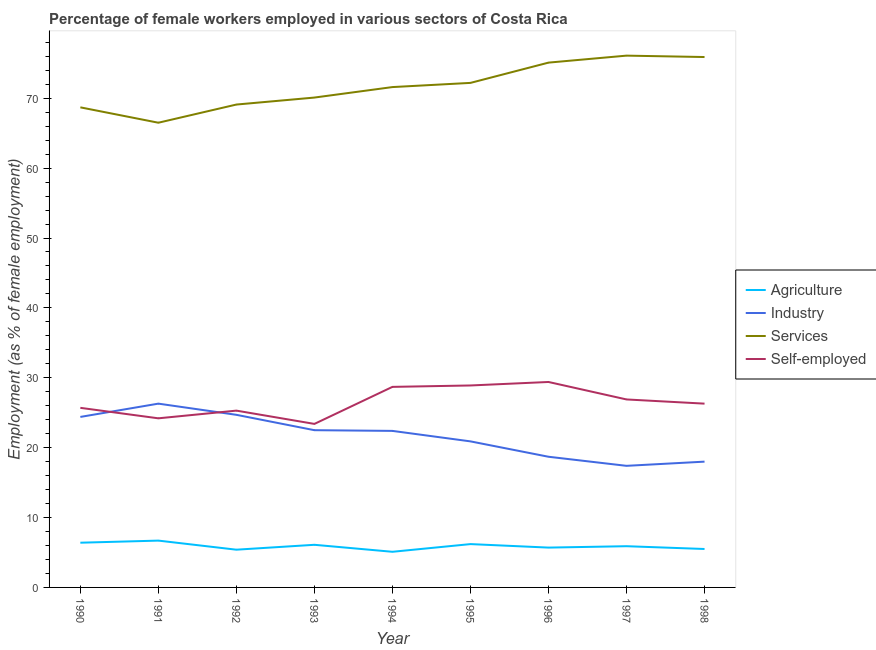Does the line corresponding to percentage of self employed female workers intersect with the line corresponding to percentage of female workers in services?
Give a very brief answer. No. Is the number of lines equal to the number of legend labels?
Provide a short and direct response. Yes. What is the percentage of female workers in services in 1993?
Make the answer very short. 70.1. Across all years, what is the maximum percentage of female workers in industry?
Your answer should be very brief. 26.3. Across all years, what is the minimum percentage of self employed female workers?
Ensure brevity in your answer.  23.4. In which year was the percentage of female workers in services maximum?
Keep it short and to the point. 1997. In which year was the percentage of female workers in services minimum?
Keep it short and to the point. 1991. What is the total percentage of female workers in services in the graph?
Offer a very short reply. 645.3. What is the difference between the percentage of female workers in industry in 1994 and that in 1997?
Provide a succinct answer. 5. What is the difference between the percentage of female workers in services in 1993 and the percentage of female workers in industry in 1997?
Offer a terse response. 52.7. What is the average percentage of female workers in agriculture per year?
Keep it short and to the point. 5.89. In the year 1996, what is the difference between the percentage of female workers in industry and percentage of self employed female workers?
Ensure brevity in your answer.  -10.7. What is the ratio of the percentage of self employed female workers in 1990 to that in 1996?
Provide a succinct answer. 0.87. Is the percentage of female workers in services in 1995 less than that in 1996?
Ensure brevity in your answer.  Yes. What is the difference between the highest and the second highest percentage of self employed female workers?
Offer a very short reply. 0.5. What is the difference between the highest and the lowest percentage of female workers in services?
Your response must be concise. 9.6. Is it the case that in every year, the sum of the percentage of female workers in agriculture and percentage of self employed female workers is greater than the sum of percentage of female workers in services and percentage of female workers in industry?
Keep it short and to the point. No. Is it the case that in every year, the sum of the percentage of female workers in agriculture and percentage of female workers in industry is greater than the percentage of female workers in services?
Ensure brevity in your answer.  No. Does the percentage of female workers in agriculture monotonically increase over the years?
Your answer should be compact. No. Is the percentage of self employed female workers strictly less than the percentage of female workers in industry over the years?
Make the answer very short. No. How many years are there in the graph?
Give a very brief answer. 9. What is the difference between two consecutive major ticks on the Y-axis?
Make the answer very short. 10. Are the values on the major ticks of Y-axis written in scientific E-notation?
Give a very brief answer. No. Does the graph contain any zero values?
Offer a very short reply. No. What is the title of the graph?
Keep it short and to the point. Percentage of female workers employed in various sectors of Costa Rica. What is the label or title of the Y-axis?
Ensure brevity in your answer.  Employment (as % of female employment). What is the Employment (as % of female employment) in Agriculture in 1990?
Offer a terse response. 6.4. What is the Employment (as % of female employment) of Industry in 1990?
Your answer should be very brief. 24.4. What is the Employment (as % of female employment) in Services in 1990?
Give a very brief answer. 68.7. What is the Employment (as % of female employment) in Self-employed in 1990?
Provide a succinct answer. 25.7. What is the Employment (as % of female employment) of Agriculture in 1991?
Keep it short and to the point. 6.7. What is the Employment (as % of female employment) of Industry in 1991?
Keep it short and to the point. 26.3. What is the Employment (as % of female employment) of Services in 1991?
Provide a succinct answer. 66.5. What is the Employment (as % of female employment) in Self-employed in 1991?
Your response must be concise. 24.2. What is the Employment (as % of female employment) in Agriculture in 1992?
Offer a very short reply. 5.4. What is the Employment (as % of female employment) in Industry in 1992?
Keep it short and to the point. 24.7. What is the Employment (as % of female employment) in Services in 1992?
Keep it short and to the point. 69.1. What is the Employment (as % of female employment) of Self-employed in 1992?
Your answer should be very brief. 25.3. What is the Employment (as % of female employment) in Agriculture in 1993?
Offer a very short reply. 6.1. What is the Employment (as % of female employment) in Industry in 1993?
Ensure brevity in your answer.  22.5. What is the Employment (as % of female employment) of Services in 1993?
Offer a terse response. 70.1. What is the Employment (as % of female employment) in Self-employed in 1993?
Give a very brief answer. 23.4. What is the Employment (as % of female employment) in Agriculture in 1994?
Offer a very short reply. 5.1. What is the Employment (as % of female employment) of Industry in 1994?
Your answer should be compact. 22.4. What is the Employment (as % of female employment) of Services in 1994?
Keep it short and to the point. 71.6. What is the Employment (as % of female employment) of Self-employed in 1994?
Provide a succinct answer. 28.7. What is the Employment (as % of female employment) of Agriculture in 1995?
Your response must be concise. 6.2. What is the Employment (as % of female employment) of Industry in 1995?
Provide a short and direct response. 20.9. What is the Employment (as % of female employment) in Services in 1995?
Offer a very short reply. 72.2. What is the Employment (as % of female employment) in Self-employed in 1995?
Your answer should be very brief. 28.9. What is the Employment (as % of female employment) of Agriculture in 1996?
Your answer should be very brief. 5.7. What is the Employment (as % of female employment) in Industry in 1996?
Provide a short and direct response. 18.7. What is the Employment (as % of female employment) of Services in 1996?
Your answer should be compact. 75.1. What is the Employment (as % of female employment) in Self-employed in 1996?
Keep it short and to the point. 29.4. What is the Employment (as % of female employment) of Agriculture in 1997?
Offer a very short reply. 5.9. What is the Employment (as % of female employment) of Industry in 1997?
Keep it short and to the point. 17.4. What is the Employment (as % of female employment) in Services in 1997?
Ensure brevity in your answer.  76.1. What is the Employment (as % of female employment) of Self-employed in 1997?
Offer a terse response. 26.9. What is the Employment (as % of female employment) of Agriculture in 1998?
Make the answer very short. 5.5. What is the Employment (as % of female employment) of Services in 1998?
Your response must be concise. 75.9. What is the Employment (as % of female employment) of Self-employed in 1998?
Provide a short and direct response. 26.3. Across all years, what is the maximum Employment (as % of female employment) in Agriculture?
Your response must be concise. 6.7. Across all years, what is the maximum Employment (as % of female employment) in Industry?
Provide a short and direct response. 26.3. Across all years, what is the maximum Employment (as % of female employment) of Services?
Your answer should be very brief. 76.1. Across all years, what is the maximum Employment (as % of female employment) in Self-employed?
Make the answer very short. 29.4. Across all years, what is the minimum Employment (as % of female employment) of Agriculture?
Provide a short and direct response. 5.1. Across all years, what is the minimum Employment (as % of female employment) of Industry?
Make the answer very short. 17.4. Across all years, what is the minimum Employment (as % of female employment) of Services?
Your answer should be very brief. 66.5. Across all years, what is the minimum Employment (as % of female employment) of Self-employed?
Your answer should be compact. 23.4. What is the total Employment (as % of female employment) of Agriculture in the graph?
Offer a very short reply. 53. What is the total Employment (as % of female employment) in Industry in the graph?
Provide a short and direct response. 195.3. What is the total Employment (as % of female employment) in Services in the graph?
Provide a succinct answer. 645.3. What is the total Employment (as % of female employment) in Self-employed in the graph?
Keep it short and to the point. 238.8. What is the difference between the Employment (as % of female employment) of Industry in 1990 and that in 1991?
Keep it short and to the point. -1.9. What is the difference between the Employment (as % of female employment) in Services in 1990 and that in 1991?
Offer a very short reply. 2.2. What is the difference between the Employment (as % of female employment) in Self-employed in 1990 and that in 1991?
Your answer should be compact. 1.5. What is the difference between the Employment (as % of female employment) of Agriculture in 1990 and that in 1992?
Offer a terse response. 1. What is the difference between the Employment (as % of female employment) in Industry in 1990 and that in 1992?
Give a very brief answer. -0.3. What is the difference between the Employment (as % of female employment) in Self-employed in 1990 and that in 1992?
Ensure brevity in your answer.  0.4. What is the difference between the Employment (as % of female employment) of Agriculture in 1990 and that in 1993?
Provide a succinct answer. 0.3. What is the difference between the Employment (as % of female employment) in Services in 1990 and that in 1993?
Give a very brief answer. -1.4. What is the difference between the Employment (as % of female employment) in Agriculture in 1990 and that in 1994?
Give a very brief answer. 1.3. What is the difference between the Employment (as % of female employment) in Self-employed in 1990 and that in 1994?
Offer a very short reply. -3. What is the difference between the Employment (as % of female employment) in Services in 1990 and that in 1995?
Make the answer very short. -3.5. What is the difference between the Employment (as % of female employment) in Industry in 1990 and that in 1996?
Your response must be concise. 5.7. What is the difference between the Employment (as % of female employment) of Agriculture in 1990 and that in 1998?
Give a very brief answer. 0.9. What is the difference between the Employment (as % of female employment) in Industry in 1990 and that in 1998?
Provide a short and direct response. 6.4. What is the difference between the Employment (as % of female employment) in Self-employed in 1990 and that in 1998?
Ensure brevity in your answer.  -0.6. What is the difference between the Employment (as % of female employment) of Services in 1991 and that in 1992?
Provide a succinct answer. -2.6. What is the difference between the Employment (as % of female employment) of Self-employed in 1991 and that in 1992?
Make the answer very short. -1.1. What is the difference between the Employment (as % of female employment) in Agriculture in 1991 and that in 1993?
Offer a terse response. 0.6. What is the difference between the Employment (as % of female employment) in Industry in 1991 and that in 1993?
Your answer should be very brief. 3.8. What is the difference between the Employment (as % of female employment) in Agriculture in 1991 and that in 1994?
Provide a short and direct response. 1.6. What is the difference between the Employment (as % of female employment) in Agriculture in 1991 and that in 1995?
Your response must be concise. 0.5. What is the difference between the Employment (as % of female employment) of Services in 1991 and that in 1995?
Keep it short and to the point. -5.7. What is the difference between the Employment (as % of female employment) of Self-employed in 1991 and that in 1995?
Provide a short and direct response. -4.7. What is the difference between the Employment (as % of female employment) in Agriculture in 1991 and that in 1996?
Your answer should be very brief. 1. What is the difference between the Employment (as % of female employment) in Services in 1991 and that in 1996?
Provide a succinct answer. -8.6. What is the difference between the Employment (as % of female employment) of Agriculture in 1991 and that in 1997?
Ensure brevity in your answer.  0.8. What is the difference between the Employment (as % of female employment) in Industry in 1991 and that in 1997?
Your answer should be compact. 8.9. What is the difference between the Employment (as % of female employment) in Self-employed in 1991 and that in 1997?
Provide a succinct answer. -2.7. What is the difference between the Employment (as % of female employment) in Services in 1991 and that in 1998?
Provide a succinct answer. -9.4. What is the difference between the Employment (as % of female employment) in Industry in 1992 and that in 1993?
Give a very brief answer. 2.2. What is the difference between the Employment (as % of female employment) in Services in 1992 and that in 1993?
Give a very brief answer. -1. What is the difference between the Employment (as % of female employment) in Self-employed in 1992 and that in 1993?
Give a very brief answer. 1.9. What is the difference between the Employment (as % of female employment) in Services in 1992 and that in 1994?
Offer a very short reply. -2.5. What is the difference between the Employment (as % of female employment) in Agriculture in 1992 and that in 1995?
Keep it short and to the point. -0.8. What is the difference between the Employment (as % of female employment) of Services in 1992 and that in 1995?
Make the answer very short. -3.1. What is the difference between the Employment (as % of female employment) of Self-employed in 1992 and that in 1995?
Offer a terse response. -3.6. What is the difference between the Employment (as % of female employment) of Agriculture in 1992 and that in 1996?
Give a very brief answer. -0.3. What is the difference between the Employment (as % of female employment) in Industry in 1992 and that in 1996?
Provide a succinct answer. 6. What is the difference between the Employment (as % of female employment) in Services in 1992 and that in 1996?
Offer a very short reply. -6. What is the difference between the Employment (as % of female employment) in Industry in 1992 and that in 1997?
Offer a terse response. 7.3. What is the difference between the Employment (as % of female employment) of Services in 1992 and that in 1997?
Ensure brevity in your answer.  -7. What is the difference between the Employment (as % of female employment) of Self-employed in 1992 and that in 1997?
Your response must be concise. -1.6. What is the difference between the Employment (as % of female employment) in Agriculture in 1992 and that in 1998?
Offer a terse response. -0.1. What is the difference between the Employment (as % of female employment) in Industry in 1992 and that in 1998?
Your answer should be compact. 6.7. What is the difference between the Employment (as % of female employment) in Industry in 1993 and that in 1994?
Provide a short and direct response. 0.1. What is the difference between the Employment (as % of female employment) in Services in 1993 and that in 1994?
Provide a succinct answer. -1.5. What is the difference between the Employment (as % of female employment) in Self-employed in 1993 and that in 1994?
Provide a short and direct response. -5.3. What is the difference between the Employment (as % of female employment) in Industry in 1993 and that in 1995?
Offer a terse response. 1.6. What is the difference between the Employment (as % of female employment) of Services in 1993 and that in 1995?
Offer a terse response. -2.1. What is the difference between the Employment (as % of female employment) of Self-employed in 1993 and that in 1995?
Your response must be concise. -5.5. What is the difference between the Employment (as % of female employment) of Industry in 1993 and that in 1996?
Your answer should be compact. 3.8. What is the difference between the Employment (as % of female employment) in Services in 1993 and that in 1996?
Your answer should be very brief. -5. What is the difference between the Employment (as % of female employment) of Industry in 1993 and that in 1997?
Your response must be concise. 5.1. What is the difference between the Employment (as % of female employment) of Agriculture in 1993 and that in 1998?
Your response must be concise. 0.6. What is the difference between the Employment (as % of female employment) in Services in 1993 and that in 1998?
Give a very brief answer. -5.8. What is the difference between the Employment (as % of female employment) of Self-employed in 1993 and that in 1998?
Keep it short and to the point. -2.9. What is the difference between the Employment (as % of female employment) in Industry in 1994 and that in 1995?
Make the answer very short. 1.5. What is the difference between the Employment (as % of female employment) of Services in 1994 and that in 1995?
Offer a terse response. -0.6. What is the difference between the Employment (as % of female employment) of Self-employed in 1994 and that in 1995?
Make the answer very short. -0.2. What is the difference between the Employment (as % of female employment) of Industry in 1994 and that in 1996?
Your response must be concise. 3.7. What is the difference between the Employment (as % of female employment) in Self-employed in 1994 and that in 1996?
Make the answer very short. -0.7. What is the difference between the Employment (as % of female employment) of Industry in 1994 and that in 1997?
Ensure brevity in your answer.  5. What is the difference between the Employment (as % of female employment) in Services in 1994 and that in 1997?
Your answer should be compact. -4.5. What is the difference between the Employment (as % of female employment) in Self-employed in 1994 and that in 1997?
Ensure brevity in your answer.  1.8. What is the difference between the Employment (as % of female employment) in Agriculture in 1994 and that in 1998?
Provide a short and direct response. -0.4. What is the difference between the Employment (as % of female employment) in Industry in 1994 and that in 1998?
Your answer should be compact. 4.4. What is the difference between the Employment (as % of female employment) of Self-employed in 1994 and that in 1998?
Offer a terse response. 2.4. What is the difference between the Employment (as % of female employment) of Agriculture in 1995 and that in 1996?
Your response must be concise. 0.5. What is the difference between the Employment (as % of female employment) in Industry in 1995 and that in 1996?
Offer a terse response. 2.2. What is the difference between the Employment (as % of female employment) of Services in 1995 and that in 1996?
Your answer should be compact. -2.9. What is the difference between the Employment (as % of female employment) of Services in 1995 and that in 1997?
Offer a very short reply. -3.9. What is the difference between the Employment (as % of female employment) of Self-employed in 1995 and that in 1997?
Offer a very short reply. 2. What is the difference between the Employment (as % of female employment) in Services in 1995 and that in 1998?
Your answer should be compact. -3.7. What is the difference between the Employment (as % of female employment) in Agriculture in 1996 and that in 1997?
Offer a terse response. -0.2. What is the difference between the Employment (as % of female employment) of Services in 1996 and that in 1997?
Offer a very short reply. -1. What is the difference between the Employment (as % of female employment) in Self-employed in 1996 and that in 1997?
Give a very brief answer. 2.5. What is the difference between the Employment (as % of female employment) in Industry in 1996 and that in 1998?
Your answer should be very brief. 0.7. What is the difference between the Employment (as % of female employment) in Services in 1996 and that in 1998?
Your answer should be very brief. -0.8. What is the difference between the Employment (as % of female employment) in Self-employed in 1996 and that in 1998?
Offer a terse response. 3.1. What is the difference between the Employment (as % of female employment) in Industry in 1997 and that in 1998?
Provide a succinct answer. -0.6. What is the difference between the Employment (as % of female employment) in Services in 1997 and that in 1998?
Provide a succinct answer. 0.2. What is the difference between the Employment (as % of female employment) in Agriculture in 1990 and the Employment (as % of female employment) in Industry in 1991?
Keep it short and to the point. -19.9. What is the difference between the Employment (as % of female employment) of Agriculture in 1990 and the Employment (as % of female employment) of Services in 1991?
Offer a terse response. -60.1. What is the difference between the Employment (as % of female employment) in Agriculture in 1990 and the Employment (as % of female employment) in Self-employed in 1991?
Your response must be concise. -17.8. What is the difference between the Employment (as % of female employment) of Industry in 1990 and the Employment (as % of female employment) of Services in 1991?
Offer a terse response. -42.1. What is the difference between the Employment (as % of female employment) of Services in 1990 and the Employment (as % of female employment) of Self-employed in 1991?
Provide a short and direct response. 44.5. What is the difference between the Employment (as % of female employment) in Agriculture in 1990 and the Employment (as % of female employment) in Industry in 1992?
Keep it short and to the point. -18.3. What is the difference between the Employment (as % of female employment) in Agriculture in 1990 and the Employment (as % of female employment) in Services in 1992?
Provide a succinct answer. -62.7. What is the difference between the Employment (as % of female employment) of Agriculture in 1990 and the Employment (as % of female employment) of Self-employed in 1992?
Your answer should be very brief. -18.9. What is the difference between the Employment (as % of female employment) in Industry in 1990 and the Employment (as % of female employment) in Services in 1992?
Give a very brief answer. -44.7. What is the difference between the Employment (as % of female employment) of Industry in 1990 and the Employment (as % of female employment) of Self-employed in 1992?
Give a very brief answer. -0.9. What is the difference between the Employment (as % of female employment) of Services in 1990 and the Employment (as % of female employment) of Self-employed in 1992?
Keep it short and to the point. 43.4. What is the difference between the Employment (as % of female employment) in Agriculture in 1990 and the Employment (as % of female employment) in Industry in 1993?
Keep it short and to the point. -16.1. What is the difference between the Employment (as % of female employment) in Agriculture in 1990 and the Employment (as % of female employment) in Services in 1993?
Provide a succinct answer. -63.7. What is the difference between the Employment (as % of female employment) of Industry in 1990 and the Employment (as % of female employment) of Services in 1993?
Your answer should be compact. -45.7. What is the difference between the Employment (as % of female employment) in Services in 1990 and the Employment (as % of female employment) in Self-employed in 1993?
Your answer should be very brief. 45.3. What is the difference between the Employment (as % of female employment) of Agriculture in 1990 and the Employment (as % of female employment) of Services in 1994?
Your response must be concise. -65.2. What is the difference between the Employment (as % of female employment) in Agriculture in 1990 and the Employment (as % of female employment) in Self-employed in 1994?
Your response must be concise. -22.3. What is the difference between the Employment (as % of female employment) in Industry in 1990 and the Employment (as % of female employment) in Services in 1994?
Offer a terse response. -47.2. What is the difference between the Employment (as % of female employment) in Industry in 1990 and the Employment (as % of female employment) in Self-employed in 1994?
Offer a terse response. -4.3. What is the difference between the Employment (as % of female employment) in Agriculture in 1990 and the Employment (as % of female employment) in Industry in 1995?
Your response must be concise. -14.5. What is the difference between the Employment (as % of female employment) of Agriculture in 1990 and the Employment (as % of female employment) of Services in 1995?
Provide a short and direct response. -65.8. What is the difference between the Employment (as % of female employment) in Agriculture in 1990 and the Employment (as % of female employment) in Self-employed in 1995?
Offer a very short reply. -22.5. What is the difference between the Employment (as % of female employment) of Industry in 1990 and the Employment (as % of female employment) of Services in 1995?
Ensure brevity in your answer.  -47.8. What is the difference between the Employment (as % of female employment) in Services in 1990 and the Employment (as % of female employment) in Self-employed in 1995?
Your answer should be very brief. 39.8. What is the difference between the Employment (as % of female employment) of Agriculture in 1990 and the Employment (as % of female employment) of Services in 1996?
Ensure brevity in your answer.  -68.7. What is the difference between the Employment (as % of female employment) of Industry in 1990 and the Employment (as % of female employment) of Services in 1996?
Offer a terse response. -50.7. What is the difference between the Employment (as % of female employment) in Services in 1990 and the Employment (as % of female employment) in Self-employed in 1996?
Ensure brevity in your answer.  39.3. What is the difference between the Employment (as % of female employment) of Agriculture in 1990 and the Employment (as % of female employment) of Services in 1997?
Provide a short and direct response. -69.7. What is the difference between the Employment (as % of female employment) of Agriculture in 1990 and the Employment (as % of female employment) of Self-employed in 1997?
Keep it short and to the point. -20.5. What is the difference between the Employment (as % of female employment) in Industry in 1990 and the Employment (as % of female employment) in Services in 1997?
Offer a terse response. -51.7. What is the difference between the Employment (as % of female employment) in Industry in 1990 and the Employment (as % of female employment) in Self-employed in 1997?
Keep it short and to the point. -2.5. What is the difference between the Employment (as % of female employment) in Services in 1990 and the Employment (as % of female employment) in Self-employed in 1997?
Keep it short and to the point. 41.8. What is the difference between the Employment (as % of female employment) in Agriculture in 1990 and the Employment (as % of female employment) in Services in 1998?
Provide a succinct answer. -69.5. What is the difference between the Employment (as % of female employment) in Agriculture in 1990 and the Employment (as % of female employment) in Self-employed in 1998?
Provide a short and direct response. -19.9. What is the difference between the Employment (as % of female employment) in Industry in 1990 and the Employment (as % of female employment) in Services in 1998?
Your answer should be compact. -51.5. What is the difference between the Employment (as % of female employment) in Industry in 1990 and the Employment (as % of female employment) in Self-employed in 1998?
Give a very brief answer. -1.9. What is the difference between the Employment (as % of female employment) in Services in 1990 and the Employment (as % of female employment) in Self-employed in 1998?
Offer a very short reply. 42.4. What is the difference between the Employment (as % of female employment) in Agriculture in 1991 and the Employment (as % of female employment) in Industry in 1992?
Make the answer very short. -18. What is the difference between the Employment (as % of female employment) of Agriculture in 1991 and the Employment (as % of female employment) of Services in 1992?
Your answer should be very brief. -62.4. What is the difference between the Employment (as % of female employment) in Agriculture in 1991 and the Employment (as % of female employment) in Self-employed in 1992?
Your answer should be very brief. -18.6. What is the difference between the Employment (as % of female employment) in Industry in 1991 and the Employment (as % of female employment) in Services in 1992?
Your response must be concise. -42.8. What is the difference between the Employment (as % of female employment) of Services in 1991 and the Employment (as % of female employment) of Self-employed in 1992?
Provide a short and direct response. 41.2. What is the difference between the Employment (as % of female employment) of Agriculture in 1991 and the Employment (as % of female employment) of Industry in 1993?
Your answer should be compact. -15.8. What is the difference between the Employment (as % of female employment) in Agriculture in 1991 and the Employment (as % of female employment) in Services in 1993?
Your answer should be compact. -63.4. What is the difference between the Employment (as % of female employment) in Agriculture in 1991 and the Employment (as % of female employment) in Self-employed in 1993?
Ensure brevity in your answer.  -16.7. What is the difference between the Employment (as % of female employment) of Industry in 1991 and the Employment (as % of female employment) of Services in 1993?
Keep it short and to the point. -43.8. What is the difference between the Employment (as % of female employment) of Industry in 1991 and the Employment (as % of female employment) of Self-employed in 1993?
Offer a very short reply. 2.9. What is the difference between the Employment (as % of female employment) of Services in 1991 and the Employment (as % of female employment) of Self-employed in 1993?
Ensure brevity in your answer.  43.1. What is the difference between the Employment (as % of female employment) in Agriculture in 1991 and the Employment (as % of female employment) in Industry in 1994?
Keep it short and to the point. -15.7. What is the difference between the Employment (as % of female employment) in Agriculture in 1991 and the Employment (as % of female employment) in Services in 1994?
Offer a terse response. -64.9. What is the difference between the Employment (as % of female employment) in Industry in 1991 and the Employment (as % of female employment) in Services in 1994?
Offer a terse response. -45.3. What is the difference between the Employment (as % of female employment) in Services in 1991 and the Employment (as % of female employment) in Self-employed in 1994?
Make the answer very short. 37.8. What is the difference between the Employment (as % of female employment) in Agriculture in 1991 and the Employment (as % of female employment) in Services in 1995?
Give a very brief answer. -65.5. What is the difference between the Employment (as % of female employment) in Agriculture in 1991 and the Employment (as % of female employment) in Self-employed in 1995?
Your answer should be very brief. -22.2. What is the difference between the Employment (as % of female employment) in Industry in 1991 and the Employment (as % of female employment) in Services in 1995?
Give a very brief answer. -45.9. What is the difference between the Employment (as % of female employment) in Industry in 1991 and the Employment (as % of female employment) in Self-employed in 1995?
Ensure brevity in your answer.  -2.6. What is the difference between the Employment (as % of female employment) in Services in 1991 and the Employment (as % of female employment) in Self-employed in 1995?
Your answer should be very brief. 37.6. What is the difference between the Employment (as % of female employment) of Agriculture in 1991 and the Employment (as % of female employment) of Services in 1996?
Your answer should be very brief. -68.4. What is the difference between the Employment (as % of female employment) of Agriculture in 1991 and the Employment (as % of female employment) of Self-employed in 1996?
Your response must be concise. -22.7. What is the difference between the Employment (as % of female employment) of Industry in 1991 and the Employment (as % of female employment) of Services in 1996?
Provide a succinct answer. -48.8. What is the difference between the Employment (as % of female employment) in Industry in 1991 and the Employment (as % of female employment) in Self-employed in 1996?
Offer a very short reply. -3.1. What is the difference between the Employment (as % of female employment) of Services in 1991 and the Employment (as % of female employment) of Self-employed in 1996?
Your answer should be very brief. 37.1. What is the difference between the Employment (as % of female employment) of Agriculture in 1991 and the Employment (as % of female employment) of Industry in 1997?
Ensure brevity in your answer.  -10.7. What is the difference between the Employment (as % of female employment) of Agriculture in 1991 and the Employment (as % of female employment) of Services in 1997?
Keep it short and to the point. -69.4. What is the difference between the Employment (as % of female employment) of Agriculture in 1991 and the Employment (as % of female employment) of Self-employed in 1997?
Give a very brief answer. -20.2. What is the difference between the Employment (as % of female employment) of Industry in 1991 and the Employment (as % of female employment) of Services in 1997?
Provide a succinct answer. -49.8. What is the difference between the Employment (as % of female employment) in Services in 1991 and the Employment (as % of female employment) in Self-employed in 1997?
Ensure brevity in your answer.  39.6. What is the difference between the Employment (as % of female employment) of Agriculture in 1991 and the Employment (as % of female employment) of Industry in 1998?
Keep it short and to the point. -11.3. What is the difference between the Employment (as % of female employment) in Agriculture in 1991 and the Employment (as % of female employment) in Services in 1998?
Provide a short and direct response. -69.2. What is the difference between the Employment (as % of female employment) in Agriculture in 1991 and the Employment (as % of female employment) in Self-employed in 1998?
Ensure brevity in your answer.  -19.6. What is the difference between the Employment (as % of female employment) in Industry in 1991 and the Employment (as % of female employment) in Services in 1998?
Your response must be concise. -49.6. What is the difference between the Employment (as % of female employment) in Services in 1991 and the Employment (as % of female employment) in Self-employed in 1998?
Provide a short and direct response. 40.2. What is the difference between the Employment (as % of female employment) of Agriculture in 1992 and the Employment (as % of female employment) of Industry in 1993?
Give a very brief answer. -17.1. What is the difference between the Employment (as % of female employment) in Agriculture in 1992 and the Employment (as % of female employment) in Services in 1993?
Give a very brief answer. -64.7. What is the difference between the Employment (as % of female employment) of Industry in 1992 and the Employment (as % of female employment) of Services in 1993?
Your response must be concise. -45.4. What is the difference between the Employment (as % of female employment) of Services in 1992 and the Employment (as % of female employment) of Self-employed in 1993?
Give a very brief answer. 45.7. What is the difference between the Employment (as % of female employment) in Agriculture in 1992 and the Employment (as % of female employment) in Services in 1994?
Your answer should be very brief. -66.2. What is the difference between the Employment (as % of female employment) in Agriculture in 1992 and the Employment (as % of female employment) in Self-employed in 1994?
Provide a short and direct response. -23.3. What is the difference between the Employment (as % of female employment) of Industry in 1992 and the Employment (as % of female employment) of Services in 1994?
Make the answer very short. -46.9. What is the difference between the Employment (as % of female employment) of Services in 1992 and the Employment (as % of female employment) of Self-employed in 1994?
Offer a terse response. 40.4. What is the difference between the Employment (as % of female employment) of Agriculture in 1992 and the Employment (as % of female employment) of Industry in 1995?
Make the answer very short. -15.5. What is the difference between the Employment (as % of female employment) in Agriculture in 1992 and the Employment (as % of female employment) in Services in 1995?
Provide a succinct answer. -66.8. What is the difference between the Employment (as % of female employment) of Agriculture in 1992 and the Employment (as % of female employment) of Self-employed in 1995?
Ensure brevity in your answer.  -23.5. What is the difference between the Employment (as % of female employment) in Industry in 1992 and the Employment (as % of female employment) in Services in 1995?
Your answer should be compact. -47.5. What is the difference between the Employment (as % of female employment) in Services in 1992 and the Employment (as % of female employment) in Self-employed in 1995?
Ensure brevity in your answer.  40.2. What is the difference between the Employment (as % of female employment) in Agriculture in 1992 and the Employment (as % of female employment) in Services in 1996?
Provide a short and direct response. -69.7. What is the difference between the Employment (as % of female employment) of Industry in 1992 and the Employment (as % of female employment) of Services in 1996?
Make the answer very short. -50.4. What is the difference between the Employment (as % of female employment) in Industry in 1992 and the Employment (as % of female employment) in Self-employed in 1996?
Ensure brevity in your answer.  -4.7. What is the difference between the Employment (as % of female employment) in Services in 1992 and the Employment (as % of female employment) in Self-employed in 1996?
Offer a terse response. 39.7. What is the difference between the Employment (as % of female employment) of Agriculture in 1992 and the Employment (as % of female employment) of Industry in 1997?
Your response must be concise. -12. What is the difference between the Employment (as % of female employment) of Agriculture in 1992 and the Employment (as % of female employment) of Services in 1997?
Your response must be concise. -70.7. What is the difference between the Employment (as % of female employment) in Agriculture in 1992 and the Employment (as % of female employment) in Self-employed in 1997?
Ensure brevity in your answer.  -21.5. What is the difference between the Employment (as % of female employment) in Industry in 1992 and the Employment (as % of female employment) in Services in 1997?
Ensure brevity in your answer.  -51.4. What is the difference between the Employment (as % of female employment) of Industry in 1992 and the Employment (as % of female employment) of Self-employed in 1997?
Your answer should be compact. -2.2. What is the difference between the Employment (as % of female employment) in Services in 1992 and the Employment (as % of female employment) in Self-employed in 1997?
Make the answer very short. 42.2. What is the difference between the Employment (as % of female employment) in Agriculture in 1992 and the Employment (as % of female employment) in Industry in 1998?
Your response must be concise. -12.6. What is the difference between the Employment (as % of female employment) of Agriculture in 1992 and the Employment (as % of female employment) of Services in 1998?
Offer a very short reply. -70.5. What is the difference between the Employment (as % of female employment) of Agriculture in 1992 and the Employment (as % of female employment) of Self-employed in 1998?
Your answer should be very brief. -20.9. What is the difference between the Employment (as % of female employment) of Industry in 1992 and the Employment (as % of female employment) of Services in 1998?
Your answer should be very brief. -51.2. What is the difference between the Employment (as % of female employment) in Services in 1992 and the Employment (as % of female employment) in Self-employed in 1998?
Your answer should be compact. 42.8. What is the difference between the Employment (as % of female employment) of Agriculture in 1993 and the Employment (as % of female employment) of Industry in 1994?
Provide a succinct answer. -16.3. What is the difference between the Employment (as % of female employment) of Agriculture in 1993 and the Employment (as % of female employment) of Services in 1994?
Ensure brevity in your answer.  -65.5. What is the difference between the Employment (as % of female employment) of Agriculture in 1993 and the Employment (as % of female employment) of Self-employed in 1994?
Offer a very short reply. -22.6. What is the difference between the Employment (as % of female employment) in Industry in 1993 and the Employment (as % of female employment) in Services in 1994?
Keep it short and to the point. -49.1. What is the difference between the Employment (as % of female employment) of Services in 1993 and the Employment (as % of female employment) of Self-employed in 1994?
Your answer should be very brief. 41.4. What is the difference between the Employment (as % of female employment) in Agriculture in 1993 and the Employment (as % of female employment) in Industry in 1995?
Offer a very short reply. -14.8. What is the difference between the Employment (as % of female employment) in Agriculture in 1993 and the Employment (as % of female employment) in Services in 1995?
Ensure brevity in your answer.  -66.1. What is the difference between the Employment (as % of female employment) of Agriculture in 1993 and the Employment (as % of female employment) of Self-employed in 1995?
Keep it short and to the point. -22.8. What is the difference between the Employment (as % of female employment) in Industry in 1993 and the Employment (as % of female employment) in Services in 1995?
Offer a terse response. -49.7. What is the difference between the Employment (as % of female employment) of Industry in 1993 and the Employment (as % of female employment) of Self-employed in 1995?
Your answer should be compact. -6.4. What is the difference between the Employment (as % of female employment) of Services in 1993 and the Employment (as % of female employment) of Self-employed in 1995?
Make the answer very short. 41.2. What is the difference between the Employment (as % of female employment) in Agriculture in 1993 and the Employment (as % of female employment) in Services in 1996?
Offer a terse response. -69. What is the difference between the Employment (as % of female employment) of Agriculture in 1993 and the Employment (as % of female employment) of Self-employed in 1996?
Offer a terse response. -23.3. What is the difference between the Employment (as % of female employment) of Industry in 1993 and the Employment (as % of female employment) of Services in 1996?
Make the answer very short. -52.6. What is the difference between the Employment (as % of female employment) in Services in 1993 and the Employment (as % of female employment) in Self-employed in 1996?
Offer a very short reply. 40.7. What is the difference between the Employment (as % of female employment) of Agriculture in 1993 and the Employment (as % of female employment) of Services in 1997?
Give a very brief answer. -70. What is the difference between the Employment (as % of female employment) of Agriculture in 1993 and the Employment (as % of female employment) of Self-employed in 1997?
Keep it short and to the point. -20.8. What is the difference between the Employment (as % of female employment) of Industry in 1993 and the Employment (as % of female employment) of Services in 1997?
Offer a terse response. -53.6. What is the difference between the Employment (as % of female employment) of Industry in 1993 and the Employment (as % of female employment) of Self-employed in 1997?
Give a very brief answer. -4.4. What is the difference between the Employment (as % of female employment) of Services in 1993 and the Employment (as % of female employment) of Self-employed in 1997?
Make the answer very short. 43.2. What is the difference between the Employment (as % of female employment) of Agriculture in 1993 and the Employment (as % of female employment) of Industry in 1998?
Your answer should be compact. -11.9. What is the difference between the Employment (as % of female employment) in Agriculture in 1993 and the Employment (as % of female employment) in Services in 1998?
Provide a succinct answer. -69.8. What is the difference between the Employment (as % of female employment) in Agriculture in 1993 and the Employment (as % of female employment) in Self-employed in 1998?
Provide a short and direct response. -20.2. What is the difference between the Employment (as % of female employment) in Industry in 1993 and the Employment (as % of female employment) in Services in 1998?
Ensure brevity in your answer.  -53.4. What is the difference between the Employment (as % of female employment) in Industry in 1993 and the Employment (as % of female employment) in Self-employed in 1998?
Offer a very short reply. -3.8. What is the difference between the Employment (as % of female employment) in Services in 1993 and the Employment (as % of female employment) in Self-employed in 1998?
Offer a terse response. 43.8. What is the difference between the Employment (as % of female employment) of Agriculture in 1994 and the Employment (as % of female employment) of Industry in 1995?
Your answer should be compact. -15.8. What is the difference between the Employment (as % of female employment) of Agriculture in 1994 and the Employment (as % of female employment) of Services in 1995?
Your response must be concise. -67.1. What is the difference between the Employment (as % of female employment) in Agriculture in 1994 and the Employment (as % of female employment) in Self-employed in 1995?
Keep it short and to the point. -23.8. What is the difference between the Employment (as % of female employment) in Industry in 1994 and the Employment (as % of female employment) in Services in 1995?
Ensure brevity in your answer.  -49.8. What is the difference between the Employment (as % of female employment) in Industry in 1994 and the Employment (as % of female employment) in Self-employed in 1995?
Offer a very short reply. -6.5. What is the difference between the Employment (as % of female employment) of Services in 1994 and the Employment (as % of female employment) of Self-employed in 1995?
Your answer should be compact. 42.7. What is the difference between the Employment (as % of female employment) of Agriculture in 1994 and the Employment (as % of female employment) of Industry in 1996?
Offer a terse response. -13.6. What is the difference between the Employment (as % of female employment) of Agriculture in 1994 and the Employment (as % of female employment) of Services in 1996?
Make the answer very short. -70. What is the difference between the Employment (as % of female employment) in Agriculture in 1994 and the Employment (as % of female employment) in Self-employed in 1996?
Keep it short and to the point. -24.3. What is the difference between the Employment (as % of female employment) in Industry in 1994 and the Employment (as % of female employment) in Services in 1996?
Ensure brevity in your answer.  -52.7. What is the difference between the Employment (as % of female employment) of Services in 1994 and the Employment (as % of female employment) of Self-employed in 1996?
Provide a succinct answer. 42.2. What is the difference between the Employment (as % of female employment) of Agriculture in 1994 and the Employment (as % of female employment) of Industry in 1997?
Offer a very short reply. -12.3. What is the difference between the Employment (as % of female employment) of Agriculture in 1994 and the Employment (as % of female employment) of Services in 1997?
Your answer should be very brief. -71. What is the difference between the Employment (as % of female employment) of Agriculture in 1994 and the Employment (as % of female employment) of Self-employed in 1997?
Your response must be concise. -21.8. What is the difference between the Employment (as % of female employment) of Industry in 1994 and the Employment (as % of female employment) of Services in 1997?
Offer a very short reply. -53.7. What is the difference between the Employment (as % of female employment) in Services in 1994 and the Employment (as % of female employment) in Self-employed in 1997?
Provide a short and direct response. 44.7. What is the difference between the Employment (as % of female employment) of Agriculture in 1994 and the Employment (as % of female employment) of Services in 1998?
Your answer should be very brief. -70.8. What is the difference between the Employment (as % of female employment) of Agriculture in 1994 and the Employment (as % of female employment) of Self-employed in 1998?
Offer a terse response. -21.2. What is the difference between the Employment (as % of female employment) of Industry in 1994 and the Employment (as % of female employment) of Services in 1998?
Offer a very short reply. -53.5. What is the difference between the Employment (as % of female employment) of Industry in 1994 and the Employment (as % of female employment) of Self-employed in 1998?
Provide a short and direct response. -3.9. What is the difference between the Employment (as % of female employment) of Services in 1994 and the Employment (as % of female employment) of Self-employed in 1998?
Make the answer very short. 45.3. What is the difference between the Employment (as % of female employment) of Agriculture in 1995 and the Employment (as % of female employment) of Industry in 1996?
Provide a short and direct response. -12.5. What is the difference between the Employment (as % of female employment) of Agriculture in 1995 and the Employment (as % of female employment) of Services in 1996?
Provide a short and direct response. -68.9. What is the difference between the Employment (as % of female employment) of Agriculture in 1995 and the Employment (as % of female employment) of Self-employed in 1996?
Ensure brevity in your answer.  -23.2. What is the difference between the Employment (as % of female employment) of Industry in 1995 and the Employment (as % of female employment) of Services in 1996?
Provide a short and direct response. -54.2. What is the difference between the Employment (as % of female employment) of Industry in 1995 and the Employment (as % of female employment) of Self-employed in 1996?
Provide a succinct answer. -8.5. What is the difference between the Employment (as % of female employment) in Services in 1995 and the Employment (as % of female employment) in Self-employed in 1996?
Keep it short and to the point. 42.8. What is the difference between the Employment (as % of female employment) in Agriculture in 1995 and the Employment (as % of female employment) in Industry in 1997?
Ensure brevity in your answer.  -11.2. What is the difference between the Employment (as % of female employment) in Agriculture in 1995 and the Employment (as % of female employment) in Services in 1997?
Give a very brief answer. -69.9. What is the difference between the Employment (as % of female employment) of Agriculture in 1995 and the Employment (as % of female employment) of Self-employed in 1997?
Give a very brief answer. -20.7. What is the difference between the Employment (as % of female employment) of Industry in 1995 and the Employment (as % of female employment) of Services in 1997?
Ensure brevity in your answer.  -55.2. What is the difference between the Employment (as % of female employment) of Industry in 1995 and the Employment (as % of female employment) of Self-employed in 1997?
Your response must be concise. -6. What is the difference between the Employment (as % of female employment) in Services in 1995 and the Employment (as % of female employment) in Self-employed in 1997?
Offer a very short reply. 45.3. What is the difference between the Employment (as % of female employment) in Agriculture in 1995 and the Employment (as % of female employment) in Services in 1998?
Offer a very short reply. -69.7. What is the difference between the Employment (as % of female employment) of Agriculture in 1995 and the Employment (as % of female employment) of Self-employed in 1998?
Your answer should be compact. -20.1. What is the difference between the Employment (as % of female employment) of Industry in 1995 and the Employment (as % of female employment) of Services in 1998?
Make the answer very short. -55. What is the difference between the Employment (as % of female employment) in Services in 1995 and the Employment (as % of female employment) in Self-employed in 1998?
Keep it short and to the point. 45.9. What is the difference between the Employment (as % of female employment) in Agriculture in 1996 and the Employment (as % of female employment) in Industry in 1997?
Give a very brief answer. -11.7. What is the difference between the Employment (as % of female employment) in Agriculture in 1996 and the Employment (as % of female employment) in Services in 1997?
Your answer should be very brief. -70.4. What is the difference between the Employment (as % of female employment) of Agriculture in 1996 and the Employment (as % of female employment) of Self-employed in 1997?
Your answer should be compact. -21.2. What is the difference between the Employment (as % of female employment) of Industry in 1996 and the Employment (as % of female employment) of Services in 1997?
Make the answer very short. -57.4. What is the difference between the Employment (as % of female employment) of Services in 1996 and the Employment (as % of female employment) of Self-employed in 1997?
Ensure brevity in your answer.  48.2. What is the difference between the Employment (as % of female employment) of Agriculture in 1996 and the Employment (as % of female employment) of Industry in 1998?
Give a very brief answer. -12.3. What is the difference between the Employment (as % of female employment) in Agriculture in 1996 and the Employment (as % of female employment) in Services in 1998?
Provide a short and direct response. -70.2. What is the difference between the Employment (as % of female employment) in Agriculture in 1996 and the Employment (as % of female employment) in Self-employed in 1998?
Keep it short and to the point. -20.6. What is the difference between the Employment (as % of female employment) in Industry in 1996 and the Employment (as % of female employment) in Services in 1998?
Keep it short and to the point. -57.2. What is the difference between the Employment (as % of female employment) of Services in 1996 and the Employment (as % of female employment) of Self-employed in 1998?
Provide a succinct answer. 48.8. What is the difference between the Employment (as % of female employment) in Agriculture in 1997 and the Employment (as % of female employment) in Industry in 1998?
Your response must be concise. -12.1. What is the difference between the Employment (as % of female employment) of Agriculture in 1997 and the Employment (as % of female employment) of Services in 1998?
Offer a terse response. -70. What is the difference between the Employment (as % of female employment) in Agriculture in 1997 and the Employment (as % of female employment) in Self-employed in 1998?
Ensure brevity in your answer.  -20.4. What is the difference between the Employment (as % of female employment) of Industry in 1997 and the Employment (as % of female employment) of Services in 1998?
Your response must be concise. -58.5. What is the difference between the Employment (as % of female employment) in Services in 1997 and the Employment (as % of female employment) in Self-employed in 1998?
Provide a succinct answer. 49.8. What is the average Employment (as % of female employment) in Agriculture per year?
Provide a short and direct response. 5.89. What is the average Employment (as % of female employment) in Industry per year?
Your response must be concise. 21.7. What is the average Employment (as % of female employment) in Services per year?
Make the answer very short. 71.7. What is the average Employment (as % of female employment) of Self-employed per year?
Your answer should be compact. 26.53. In the year 1990, what is the difference between the Employment (as % of female employment) of Agriculture and Employment (as % of female employment) of Services?
Ensure brevity in your answer.  -62.3. In the year 1990, what is the difference between the Employment (as % of female employment) in Agriculture and Employment (as % of female employment) in Self-employed?
Offer a terse response. -19.3. In the year 1990, what is the difference between the Employment (as % of female employment) of Industry and Employment (as % of female employment) of Services?
Offer a very short reply. -44.3. In the year 1990, what is the difference between the Employment (as % of female employment) of Services and Employment (as % of female employment) of Self-employed?
Ensure brevity in your answer.  43. In the year 1991, what is the difference between the Employment (as % of female employment) in Agriculture and Employment (as % of female employment) in Industry?
Provide a short and direct response. -19.6. In the year 1991, what is the difference between the Employment (as % of female employment) of Agriculture and Employment (as % of female employment) of Services?
Your answer should be very brief. -59.8. In the year 1991, what is the difference between the Employment (as % of female employment) of Agriculture and Employment (as % of female employment) of Self-employed?
Offer a terse response. -17.5. In the year 1991, what is the difference between the Employment (as % of female employment) of Industry and Employment (as % of female employment) of Services?
Offer a terse response. -40.2. In the year 1991, what is the difference between the Employment (as % of female employment) of Services and Employment (as % of female employment) of Self-employed?
Your answer should be compact. 42.3. In the year 1992, what is the difference between the Employment (as % of female employment) in Agriculture and Employment (as % of female employment) in Industry?
Make the answer very short. -19.3. In the year 1992, what is the difference between the Employment (as % of female employment) of Agriculture and Employment (as % of female employment) of Services?
Give a very brief answer. -63.7. In the year 1992, what is the difference between the Employment (as % of female employment) of Agriculture and Employment (as % of female employment) of Self-employed?
Give a very brief answer. -19.9. In the year 1992, what is the difference between the Employment (as % of female employment) in Industry and Employment (as % of female employment) in Services?
Your answer should be compact. -44.4. In the year 1992, what is the difference between the Employment (as % of female employment) of Industry and Employment (as % of female employment) of Self-employed?
Provide a succinct answer. -0.6. In the year 1992, what is the difference between the Employment (as % of female employment) of Services and Employment (as % of female employment) of Self-employed?
Give a very brief answer. 43.8. In the year 1993, what is the difference between the Employment (as % of female employment) of Agriculture and Employment (as % of female employment) of Industry?
Provide a short and direct response. -16.4. In the year 1993, what is the difference between the Employment (as % of female employment) in Agriculture and Employment (as % of female employment) in Services?
Give a very brief answer. -64. In the year 1993, what is the difference between the Employment (as % of female employment) in Agriculture and Employment (as % of female employment) in Self-employed?
Provide a succinct answer. -17.3. In the year 1993, what is the difference between the Employment (as % of female employment) in Industry and Employment (as % of female employment) in Services?
Offer a very short reply. -47.6. In the year 1993, what is the difference between the Employment (as % of female employment) in Industry and Employment (as % of female employment) in Self-employed?
Ensure brevity in your answer.  -0.9. In the year 1993, what is the difference between the Employment (as % of female employment) of Services and Employment (as % of female employment) of Self-employed?
Your answer should be compact. 46.7. In the year 1994, what is the difference between the Employment (as % of female employment) in Agriculture and Employment (as % of female employment) in Industry?
Make the answer very short. -17.3. In the year 1994, what is the difference between the Employment (as % of female employment) of Agriculture and Employment (as % of female employment) of Services?
Provide a short and direct response. -66.5. In the year 1994, what is the difference between the Employment (as % of female employment) in Agriculture and Employment (as % of female employment) in Self-employed?
Your answer should be compact. -23.6. In the year 1994, what is the difference between the Employment (as % of female employment) in Industry and Employment (as % of female employment) in Services?
Provide a short and direct response. -49.2. In the year 1994, what is the difference between the Employment (as % of female employment) of Services and Employment (as % of female employment) of Self-employed?
Your answer should be compact. 42.9. In the year 1995, what is the difference between the Employment (as % of female employment) in Agriculture and Employment (as % of female employment) in Industry?
Give a very brief answer. -14.7. In the year 1995, what is the difference between the Employment (as % of female employment) of Agriculture and Employment (as % of female employment) of Services?
Give a very brief answer. -66. In the year 1995, what is the difference between the Employment (as % of female employment) in Agriculture and Employment (as % of female employment) in Self-employed?
Your response must be concise. -22.7. In the year 1995, what is the difference between the Employment (as % of female employment) of Industry and Employment (as % of female employment) of Services?
Give a very brief answer. -51.3. In the year 1995, what is the difference between the Employment (as % of female employment) in Industry and Employment (as % of female employment) in Self-employed?
Ensure brevity in your answer.  -8. In the year 1995, what is the difference between the Employment (as % of female employment) of Services and Employment (as % of female employment) of Self-employed?
Give a very brief answer. 43.3. In the year 1996, what is the difference between the Employment (as % of female employment) in Agriculture and Employment (as % of female employment) in Services?
Offer a terse response. -69.4. In the year 1996, what is the difference between the Employment (as % of female employment) in Agriculture and Employment (as % of female employment) in Self-employed?
Ensure brevity in your answer.  -23.7. In the year 1996, what is the difference between the Employment (as % of female employment) of Industry and Employment (as % of female employment) of Services?
Give a very brief answer. -56.4. In the year 1996, what is the difference between the Employment (as % of female employment) in Industry and Employment (as % of female employment) in Self-employed?
Make the answer very short. -10.7. In the year 1996, what is the difference between the Employment (as % of female employment) in Services and Employment (as % of female employment) in Self-employed?
Provide a succinct answer. 45.7. In the year 1997, what is the difference between the Employment (as % of female employment) in Agriculture and Employment (as % of female employment) in Industry?
Ensure brevity in your answer.  -11.5. In the year 1997, what is the difference between the Employment (as % of female employment) of Agriculture and Employment (as % of female employment) of Services?
Provide a succinct answer. -70.2. In the year 1997, what is the difference between the Employment (as % of female employment) of Agriculture and Employment (as % of female employment) of Self-employed?
Provide a succinct answer. -21. In the year 1997, what is the difference between the Employment (as % of female employment) in Industry and Employment (as % of female employment) in Services?
Keep it short and to the point. -58.7. In the year 1997, what is the difference between the Employment (as % of female employment) of Services and Employment (as % of female employment) of Self-employed?
Your answer should be compact. 49.2. In the year 1998, what is the difference between the Employment (as % of female employment) in Agriculture and Employment (as % of female employment) in Services?
Your answer should be very brief. -70.4. In the year 1998, what is the difference between the Employment (as % of female employment) of Agriculture and Employment (as % of female employment) of Self-employed?
Your answer should be compact. -20.8. In the year 1998, what is the difference between the Employment (as % of female employment) of Industry and Employment (as % of female employment) of Services?
Your answer should be very brief. -57.9. In the year 1998, what is the difference between the Employment (as % of female employment) in Services and Employment (as % of female employment) in Self-employed?
Keep it short and to the point. 49.6. What is the ratio of the Employment (as % of female employment) of Agriculture in 1990 to that in 1991?
Make the answer very short. 0.96. What is the ratio of the Employment (as % of female employment) in Industry in 1990 to that in 1991?
Provide a short and direct response. 0.93. What is the ratio of the Employment (as % of female employment) in Services in 1990 to that in 1991?
Ensure brevity in your answer.  1.03. What is the ratio of the Employment (as % of female employment) of Self-employed in 1990 to that in 1991?
Keep it short and to the point. 1.06. What is the ratio of the Employment (as % of female employment) of Agriculture in 1990 to that in 1992?
Your answer should be very brief. 1.19. What is the ratio of the Employment (as % of female employment) of Industry in 1990 to that in 1992?
Provide a succinct answer. 0.99. What is the ratio of the Employment (as % of female employment) in Services in 1990 to that in 1992?
Make the answer very short. 0.99. What is the ratio of the Employment (as % of female employment) of Self-employed in 1990 to that in 1992?
Your response must be concise. 1.02. What is the ratio of the Employment (as % of female employment) of Agriculture in 1990 to that in 1993?
Your response must be concise. 1.05. What is the ratio of the Employment (as % of female employment) of Industry in 1990 to that in 1993?
Make the answer very short. 1.08. What is the ratio of the Employment (as % of female employment) in Services in 1990 to that in 1993?
Your answer should be very brief. 0.98. What is the ratio of the Employment (as % of female employment) of Self-employed in 1990 to that in 1993?
Offer a terse response. 1.1. What is the ratio of the Employment (as % of female employment) of Agriculture in 1990 to that in 1994?
Make the answer very short. 1.25. What is the ratio of the Employment (as % of female employment) in Industry in 1990 to that in 1994?
Ensure brevity in your answer.  1.09. What is the ratio of the Employment (as % of female employment) of Services in 1990 to that in 1994?
Ensure brevity in your answer.  0.96. What is the ratio of the Employment (as % of female employment) in Self-employed in 1990 to that in 1994?
Your answer should be compact. 0.9. What is the ratio of the Employment (as % of female employment) in Agriculture in 1990 to that in 1995?
Your answer should be compact. 1.03. What is the ratio of the Employment (as % of female employment) in Industry in 1990 to that in 1995?
Provide a short and direct response. 1.17. What is the ratio of the Employment (as % of female employment) of Services in 1990 to that in 1995?
Keep it short and to the point. 0.95. What is the ratio of the Employment (as % of female employment) of Self-employed in 1990 to that in 1995?
Your answer should be compact. 0.89. What is the ratio of the Employment (as % of female employment) of Agriculture in 1990 to that in 1996?
Keep it short and to the point. 1.12. What is the ratio of the Employment (as % of female employment) in Industry in 1990 to that in 1996?
Offer a very short reply. 1.3. What is the ratio of the Employment (as % of female employment) of Services in 1990 to that in 1996?
Your answer should be very brief. 0.91. What is the ratio of the Employment (as % of female employment) of Self-employed in 1990 to that in 1996?
Keep it short and to the point. 0.87. What is the ratio of the Employment (as % of female employment) of Agriculture in 1990 to that in 1997?
Provide a short and direct response. 1.08. What is the ratio of the Employment (as % of female employment) of Industry in 1990 to that in 1997?
Your response must be concise. 1.4. What is the ratio of the Employment (as % of female employment) of Services in 1990 to that in 1997?
Provide a short and direct response. 0.9. What is the ratio of the Employment (as % of female employment) of Self-employed in 1990 to that in 1997?
Your response must be concise. 0.96. What is the ratio of the Employment (as % of female employment) in Agriculture in 1990 to that in 1998?
Make the answer very short. 1.16. What is the ratio of the Employment (as % of female employment) of Industry in 1990 to that in 1998?
Provide a short and direct response. 1.36. What is the ratio of the Employment (as % of female employment) in Services in 1990 to that in 1998?
Ensure brevity in your answer.  0.91. What is the ratio of the Employment (as % of female employment) in Self-employed in 1990 to that in 1998?
Your response must be concise. 0.98. What is the ratio of the Employment (as % of female employment) in Agriculture in 1991 to that in 1992?
Your answer should be compact. 1.24. What is the ratio of the Employment (as % of female employment) of Industry in 1991 to that in 1992?
Ensure brevity in your answer.  1.06. What is the ratio of the Employment (as % of female employment) in Services in 1991 to that in 1992?
Give a very brief answer. 0.96. What is the ratio of the Employment (as % of female employment) in Self-employed in 1991 to that in 1992?
Offer a terse response. 0.96. What is the ratio of the Employment (as % of female employment) of Agriculture in 1991 to that in 1993?
Make the answer very short. 1.1. What is the ratio of the Employment (as % of female employment) in Industry in 1991 to that in 1993?
Provide a short and direct response. 1.17. What is the ratio of the Employment (as % of female employment) of Services in 1991 to that in 1993?
Make the answer very short. 0.95. What is the ratio of the Employment (as % of female employment) of Self-employed in 1991 to that in 1993?
Your answer should be very brief. 1.03. What is the ratio of the Employment (as % of female employment) of Agriculture in 1991 to that in 1994?
Ensure brevity in your answer.  1.31. What is the ratio of the Employment (as % of female employment) of Industry in 1991 to that in 1994?
Give a very brief answer. 1.17. What is the ratio of the Employment (as % of female employment) of Services in 1991 to that in 1994?
Your response must be concise. 0.93. What is the ratio of the Employment (as % of female employment) in Self-employed in 1991 to that in 1994?
Ensure brevity in your answer.  0.84. What is the ratio of the Employment (as % of female employment) of Agriculture in 1991 to that in 1995?
Your answer should be compact. 1.08. What is the ratio of the Employment (as % of female employment) of Industry in 1991 to that in 1995?
Keep it short and to the point. 1.26. What is the ratio of the Employment (as % of female employment) of Services in 1991 to that in 1995?
Give a very brief answer. 0.92. What is the ratio of the Employment (as % of female employment) in Self-employed in 1991 to that in 1995?
Give a very brief answer. 0.84. What is the ratio of the Employment (as % of female employment) of Agriculture in 1991 to that in 1996?
Give a very brief answer. 1.18. What is the ratio of the Employment (as % of female employment) in Industry in 1991 to that in 1996?
Provide a short and direct response. 1.41. What is the ratio of the Employment (as % of female employment) in Services in 1991 to that in 1996?
Make the answer very short. 0.89. What is the ratio of the Employment (as % of female employment) in Self-employed in 1991 to that in 1996?
Provide a succinct answer. 0.82. What is the ratio of the Employment (as % of female employment) in Agriculture in 1991 to that in 1997?
Your answer should be very brief. 1.14. What is the ratio of the Employment (as % of female employment) of Industry in 1991 to that in 1997?
Keep it short and to the point. 1.51. What is the ratio of the Employment (as % of female employment) in Services in 1991 to that in 1997?
Your response must be concise. 0.87. What is the ratio of the Employment (as % of female employment) in Self-employed in 1991 to that in 1997?
Offer a terse response. 0.9. What is the ratio of the Employment (as % of female employment) of Agriculture in 1991 to that in 1998?
Keep it short and to the point. 1.22. What is the ratio of the Employment (as % of female employment) in Industry in 1991 to that in 1998?
Your response must be concise. 1.46. What is the ratio of the Employment (as % of female employment) in Services in 1991 to that in 1998?
Your answer should be very brief. 0.88. What is the ratio of the Employment (as % of female employment) of Self-employed in 1991 to that in 1998?
Ensure brevity in your answer.  0.92. What is the ratio of the Employment (as % of female employment) in Agriculture in 1992 to that in 1993?
Your response must be concise. 0.89. What is the ratio of the Employment (as % of female employment) of Industry in 1992 to that in 1993?
Provide a succinct answer. 1.1. What is the ratio of the Employment (as % of female employment) of Services in 1992 to that in 1993?
Offer a very short reply. 0.99. What is the ratio of the Employment (as % of female employment) of Self-employed in 1992 to that in 1993?
Your answer should be compact. 1.08. What is the ratio of the Employment (as % of female employment) of Agriculture in 1992 to that in 1994?
Provide a succinct answer. 1.06. What is the ratio of the Employment (as % of female employment) in Industry in 1992 to that in 1994?
Your response must be concise. 1.1. What is the ratio of the Employment (as % of female employment) in Services in 1992 to that in 1994?
Offer a very short reply. 0.97. What is the ratio of the Employment (as % of female employment) in Self-employed in 1992 to that in 1994?
Offer a very short reply. 0.88. What is the ratio of the Employment (as % of female employment) of Agriculture in 1992 to that in 1995?
Offer a very short reply. 0.87. What is the ratio of the Employment (as % of female employment) of Industry in 1992 to that in 1995?
Give a very brief answer. 1.18. What is the ratio of the Employment (as % of female employment) of Services in 1992 to that in 1995?
Ensure brevity in your answer.  0.96. What is the ratio of the Employment (as % of female employment) in Self-employed in 1992 to that in 1995?
Your answer should be compact. 0.88. What is the ratio of the Employment (as % of female employment) in Industry in 1992 to that in 1996?
Provide a short and direct response. 1.32. What is the ratio of the Employment (as % of female employment) of Services in 1992 to that in 1996?
Your response must be concise. 0.92. What is the ratio of the Employment (as % of female employment) in Self-employed in 1992 to that in 1996?
Your answer should be very brief. 0.86. What is the ratio of the Employment (as % of female employment) of Agriculture in 1992 to that in 1997?
Keep it short and to the point. 0.92. What is the ratio of the Employment (as % of female employment) of Industry in 1992 to that in 1997?
Your answer should be compact. 1.42. What is the ratio of the Employment (as % of female employment) in Services in 1992 to that in 1997?
Your answer should be compact. 0.91. What is the ratio of the Employment (as % of female employment) of Self-employed in 1992 to that in 1997?
Your answer should be very brief. 0.94. What is the ratio of the Employment (as % of female employment) in Agriculture in 1992 to that in 1998?
Ensure brevity in your answer.  0.98. What is the ratio of the Employment (as % of female employment) in Industry in 1992 to that in 1998?
Your answer should be compact. 1.37. What is the ratio of the Employment (as % of female employment) of Services in 1992 to that in 1998?
Your response must be concise. 0.91. What is the ratio of the Employment (as % of female employment) of Agriculture in 1993 to that in 1994?
Your response must be concise. 1.2. What is the ratio of the Employment (as % of female employment) in Industry in 1993 to that in 1994?
Offer a terse response. 1. What is the ratio of the Employment (as % of female employment) of Services in 1993 to that in 1994?
Provide a succinct answer. 0.98. What is the ratio of the Employment (as % of female employment) in Self-employed in 1993 to that in 1994?
Offer a very short reply. 0.82. What is the ratio of the Employment (as % of female employment) in Agriculture in 1993 to that in 1995?
Ensure brevity in your answer.  0.98. What is the ratio of the Employment (as % of female employment) of Industry in 1993 to that in 1995?
Offer a very short reply. 1.08. What is the ratio of the Employment (as % of female employment) of Services in 1993 to that in 1995?
Your answer should be compact. 0.97. What is the ratio of the Employment (as % of female employment) of Self-employed in 1993 to that in 1995?
Give a very brief answer. 0.81. What is the ratio of the Employment (as % of female employment) in Agriculture in 1993 to that in 1996?
Provide a succinct answer. 1.07. What is the ratio of the Employment (as % of female employment) of Industry in 1993 to that in 1996?
Your answer should be very brief. 1.2. What is the ratio of the Employment (as % of female employment) in Services in 1993 to that in 1996?
Keep it short and to the point. 0.93. What is the ratio of the Employment (as % of female employment) in Self-employed in 1993 to that in 1996?
Offer a terse response. 0.8. What is the ratio of the Employment (as % of female employment) in Agriculture in 1993 to that in 1997?
Your answer should be compact. 1.03. What is the ratio of the Employment (as % of female employment) of Industry in 1993 to that in 1997?
Your answer should be compact. 1.29. What is the ratio of the Employment (as % of female employment) in Services in 1993 to that in 1997?
Your response must be concise. 0.92. What is the ratio of the Employment (as % of female employment) of Self-employed in 1993 to that in 1997?
Make the answer very short. 0.87. What is the ratio of the Employment (as % of female employment) in Agriculture in 1993 to that in 1998?
Offer a terse response. 1.11. What is the ratio of the Employment (as % of female employment) in Industry in 1993 to that in 1998?
Offer a terse response. 1.25. What is the ratio of the Employment (as % of female employment) of Services in 1993 to that in 1998?
Provide a succinct answer. 0.92. What is the ratio of the Employment (as % of female employment) in Self-employed in 1993 to that in 1998?
Your response must be concise. 0.89. What is the ratio of the Employment (as % of female employment) in Agriculture in 1994 to that in 1995?
Provide a succinct answer. 0.82. What is the ratio of the Employment (as % of female employment) in Industry in 1994 to that in 1995?
Offer a terse response. 1.07. What is the ratio of the Employment (as % of female employment) of Services in 1994 to that in 1995?
Keep it short and to the point. 0.99. What is the ratio of the Employment (as % of female employment) of Agriculture in 1994 to that in 1996?
Offer a terse response. 0.89. What is the ratio of the Employment (as % of female employment) in Industry in 1994 to that in 1996?
Provide a short and direct response. 1.2. What is the ratio of the Employment (as % of female employment) of Services in 1994 to that in 1996?
Provide a succinct answer. 0.95. What is the ratio of the Employment (as % of female employment) of Self-employed in 1994 to that in 1996?
Ensure brevity in your answer.  0.98. What is the ratio of the Employment (as % of female employment) in Agriculture in 1994 to that in 1997?
Provide a succinct answer. 0.86. What is the ratio of the Employment (as % of female employment) in Industry in 1994 to that in 1997?
Keep it short and to the point. 1.29. What is the ratio of the Employment (as % of female employment) of Services in 1994 to that in 1997?
Make the answer very short. 0.94. What is the ratio of the Employment (as % of female employment) of Self-employed in 1994 to that in 1997?
Make the answer very short. 1.07. What is the ratio of the Employment (as % of female employment) of Agriculture in 1994 to that in 1998?
Make the answer very short. 0.93. What is the ratio of the Employment (as % of female employment) of Industry in 1994 to that in 1998?
Make the answer very short. 1.24. What is the ratio of the Employment (as % of female employment) in Services in 1994 to that in 1998?
Ensure brevity in your answer.  0.94. What is the ratio of the Employment (as % of female employment) in Self-employed in 1994 to that in 1998?
Make the answer very short. 1.09. What is the ratio of the Employment (as % of female employment) of Agriculture in 1995 to that in 1996?
Give a very brief answer. 1.09. What is the ratio of the Employment (as % of female employment) in Industry in 1995 to that in 1996?
Make the answer very short. 1.12. What is the ratio of the Employment (as % of female employment) of Services in 1995 to that in 1996?
Ensure brevity in your answer.  0.96. What is the ratio of the Employment (as % of female employment) of Self-employed in 1995 to that in 1996?
Ensure brevity in your answer.  0.98. What is the ratio of the Employment (as % of female employment) of Agriculture in 1995 to that in 1997?
Your answer should be very brief. 1.05. What is the ratio of the Employment (as % of female employment) in Industry in 1995 to that in 1997?
Give a very brief answer. 1.2. What is the ratio of the Employment (as % of female employment) of Services in 1995 to that in 1997?
Offer a terse response. 0.95. What is the ratio of the Employment (as % of female employment) in Self-employed in 1995 to that in 1997?
Your answer should be compact. 1.07. What is the ratio of the Employment (as % of female employment) in Agriculture in 1995 to that in 1998?
Offer a very short reply. 1.13. What is the ratio of the Employment (as % of female employment) in Industry in 1995 to that in 1998?
Keep it short and to the point. 1.16. What is the ratio of the Employment (as % of female employment) in Services in 1995 to that in 1998?
Offer a very short reply. 0.95. What is the ratio of the Employment (as % of female employment) in Self-employed in 1995 to that in 1998?
Your answer should be very brief. 1.1. What is the ratio of the Employment (as % of female employment) in Agriculture in 1996 to that in 1997?
Provide a succinct answer. 0.97. What is the ratio of the Employment (as % of female employment) of Industry in 1996 to that in 1997?
Provide a short and direct response. 1.07. What is the ratio of the Employment (as % of female employment) in Services in 1996 to that in 1997?
Your response must be concise. 0.99. What is the ratio of the Employment (as % of female employment) of Self-employed in 1996 to that in 1997?
Your answer should be very brief. 1.09. What is the ratio of the Employment (as % of female employment) of Agriculture in 1996 to that in 1998?
Ensure brevity in your answer.  1.04. What is the ratio of the Employment (as % of female employment) of Industry in 1996 to that in 1998?
Offer a very short reply. 1.04. What is the ratio of the Employment (as % of female employment) in Services in 1996 to that in 1998?
Offer a terse response. 0.99. What is the ratio of the Employment (as % of female employment) in Self-employed in 1996 to that in 1998?
Give a very brief answer. 1.12. What is the ratio of the Employment (as % of female employment) in Agriculture in 1997 to that in 1998?
Keep it short and to the point. 1.07. What is the ratio of the Employment (as % of female employment) of Industry in 1997 to that in 1998?
Provide a succinct answer. 0.97. What is the ratio of the Employment (as % of female employment) in Self-employed in 1997 to that in 1998?
Your answer should be compact. 1.02. What is the difference between the highest and the second highest Employment (as % of female employment) in Services?
Ensure brevity in your answer.  0.2. What is the difference between the highest and the lowest Employment (as % of female employment) in Industry?
Keep it short and to the point. 8.9. What is the difference between the highest and the lowest Employment (as % of female employment) in Services?
Your answer should be very brief. 9.6. What is the difference between the highest and the lowest Employment (as % of female employment) of Self-employed?
Offer a terse response. 6. 